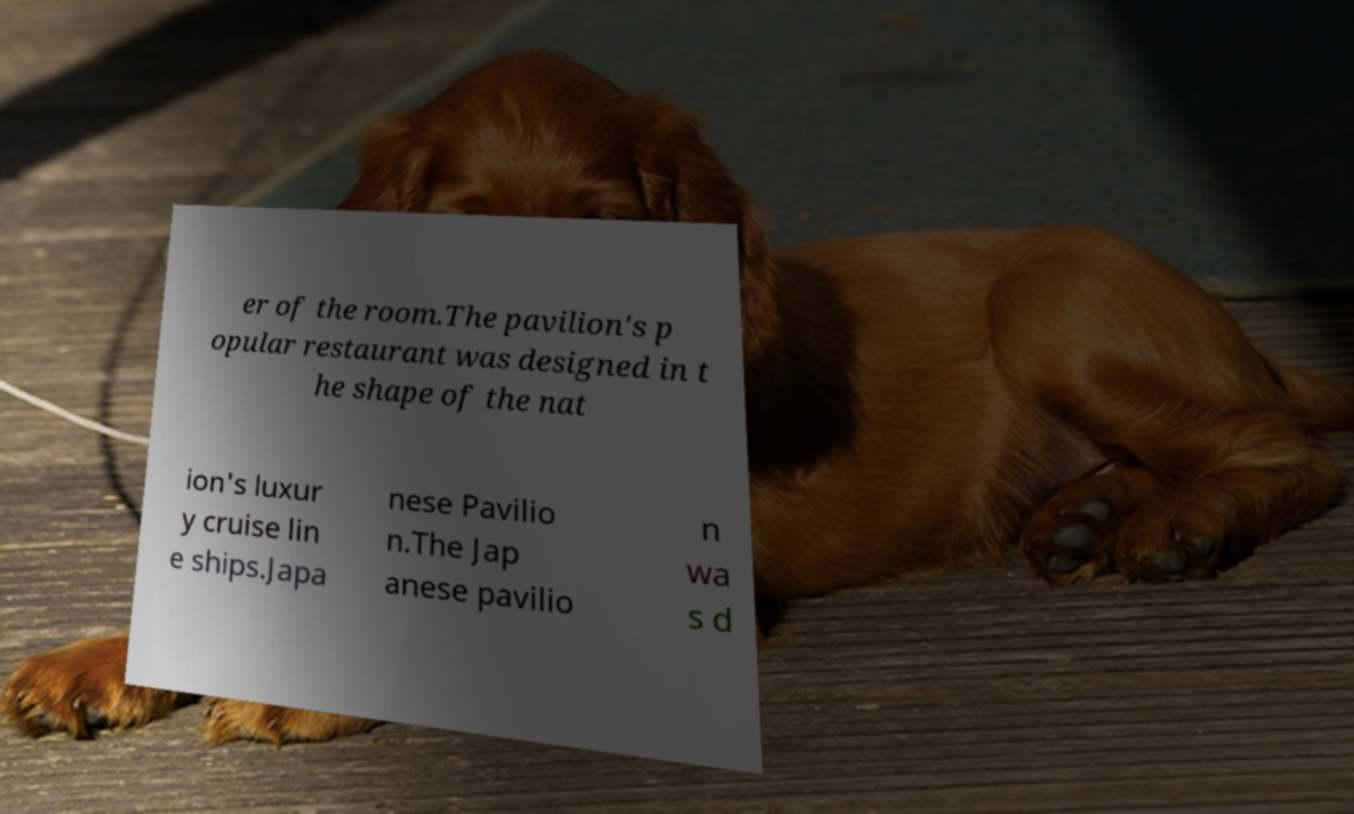What messages or text are displayed in this image? I need them in a readable, typed format. er of the room.The pavilion's p opular restaurant was designed in t he shape of the nat ion's luxur y cruise lin e ships.Japa nese Pavilio n.The Jap anese pavilio n wa s d 